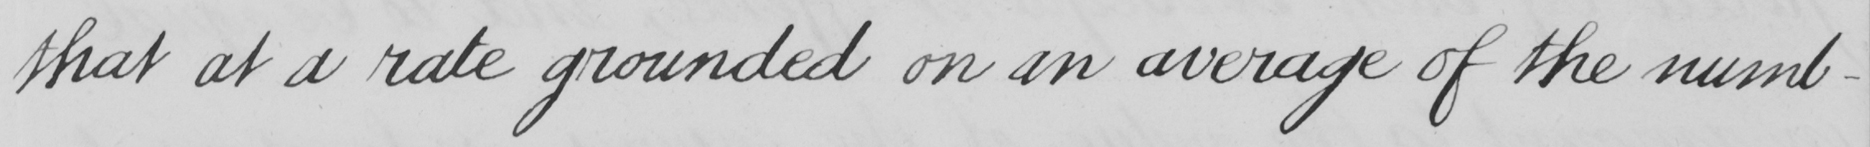Transcribe the text shown in this historical manuscript line. that at a rate grounded on an average of the numb- 